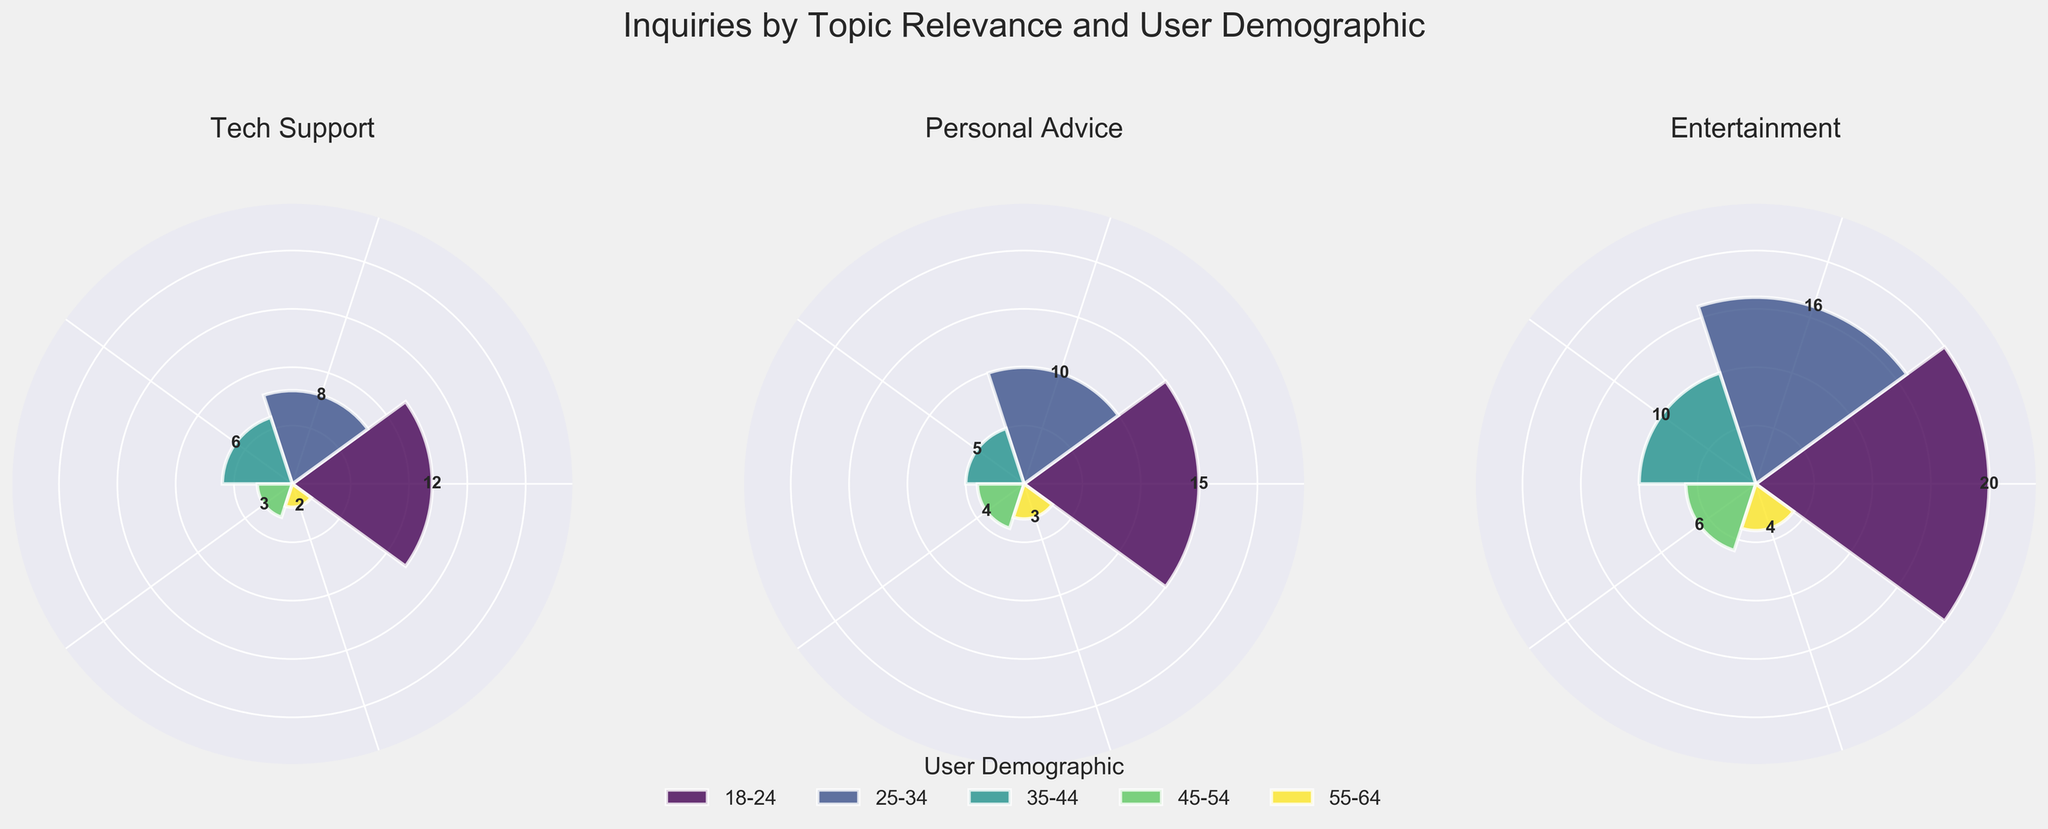What is the overall title of the figure? The overall title is located at the top of the figure and reads "Inquiries by Topic Relevance and User Demographic."
Answer: Inquiries by Topic Relevance and User Demographic Which user demographic has the highest number of inquiries for Entertainment? Look at the Entertainment subplot and identify the highest bar. The demographic 18-24 has the highest bar.
Answer: 18-24 What are the total inquiries for Tech Support from all age groups combined? Sum the values from all the age groups in the Tech Support subplot: 12 (18-24) + 8 (25-34) + 6 (35-44) + 3 (45-54) + 2 (55-64) = 31
Answer: 31 Which topic has the most inquiries from the 25-34 age group? Compare the height of the bars for the 25-34 age group across all three subplots. Entertainment has the highest bar for 25-34 with 16 inquiries.
Answer: Entertainment What is the difference between the highest and lowest inquiries for Personal Advice? Identify the highest (18-24 with 15 inquiries) and the lowest (55-64 with 3 inquiries) bars in the Personal Advice subplot. The difference is 15 - 3 = 12.
Answer: 12 Which user demographic has the lowest number of inquiries overall across all topics? For each demographic, sum up the inquiries from all three subplots and determine the smallest total:
18-24: 12 (Tech Support) +15 (Personal Advice) + 20 (Entertainment) = 47
25-34: 8 + 10 + 16 = 34
35-44: 6 + 5 + 10 = 21
45-54: 3 + 4 + 6 = 13
55-64: 2 + 3 + 4 = 9
The 55-64 age group has the lowest total.
Answer: 55-64 By how much do the inquiries for 18-24 in Personal Advice exceed those in Tech Support? Subtract the inquiries for 18-24 in Tech Support from those in Personal Advice: 15 (Personal Advice) - 12 (Tech Support) = 3
Answer: 3 What percentage of total Entertainment inquiries come from the 25-34 age group? First, find the total Entertainment inquiries by summing the values in its subplot: 20 + 16 + 10 + 6 + 4 = 56. Then, divide the number of inquiries from the 25-34 age group by that total and multiply by 100:
(16 / 56) * 100 ≈ 28.57%
Answer: 28.57% How does the frequency of inquiries for the 35-44 demographic compare between Personal Advice and Entertainment? Compare the 35-44 bars in Personal Advice (5 inquiries) and Entertainment (10 inquiries). Entertainment has twice as many inquiries as Personal Advice.
Answer: Entertainment has twice as many Which topic has the most even distribution of inquiries among all demographics? Visual inspection of each subplot shows that Personal Advice appears relatively even compared to others. The difference between the highest (15) and lowest (3) inquiries is smaller than in Tech Support and Entertainment.
Answer: Personal Advice 